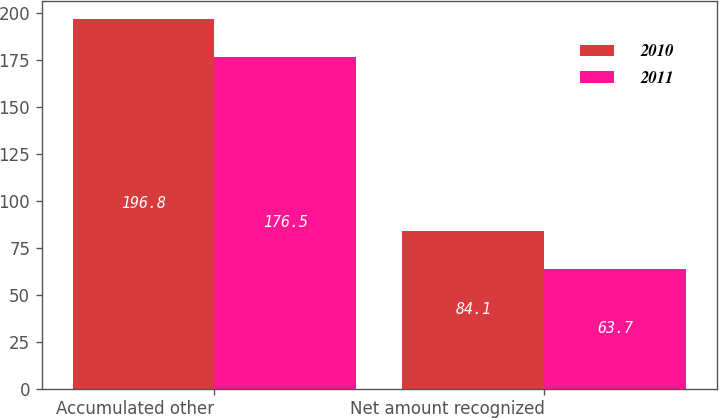Convert chart. <chart><loc_0><loc_0><loc_500><loc_500><stacked_bar_chart><ecel><fcel>Accumulated other<fcel>Net amount recognized<nl><fcel>2010<fcel>196.8<fcel>84.1<nl><fcel>2011<fcel>176.5<fcel>63.7<nl></chart> 